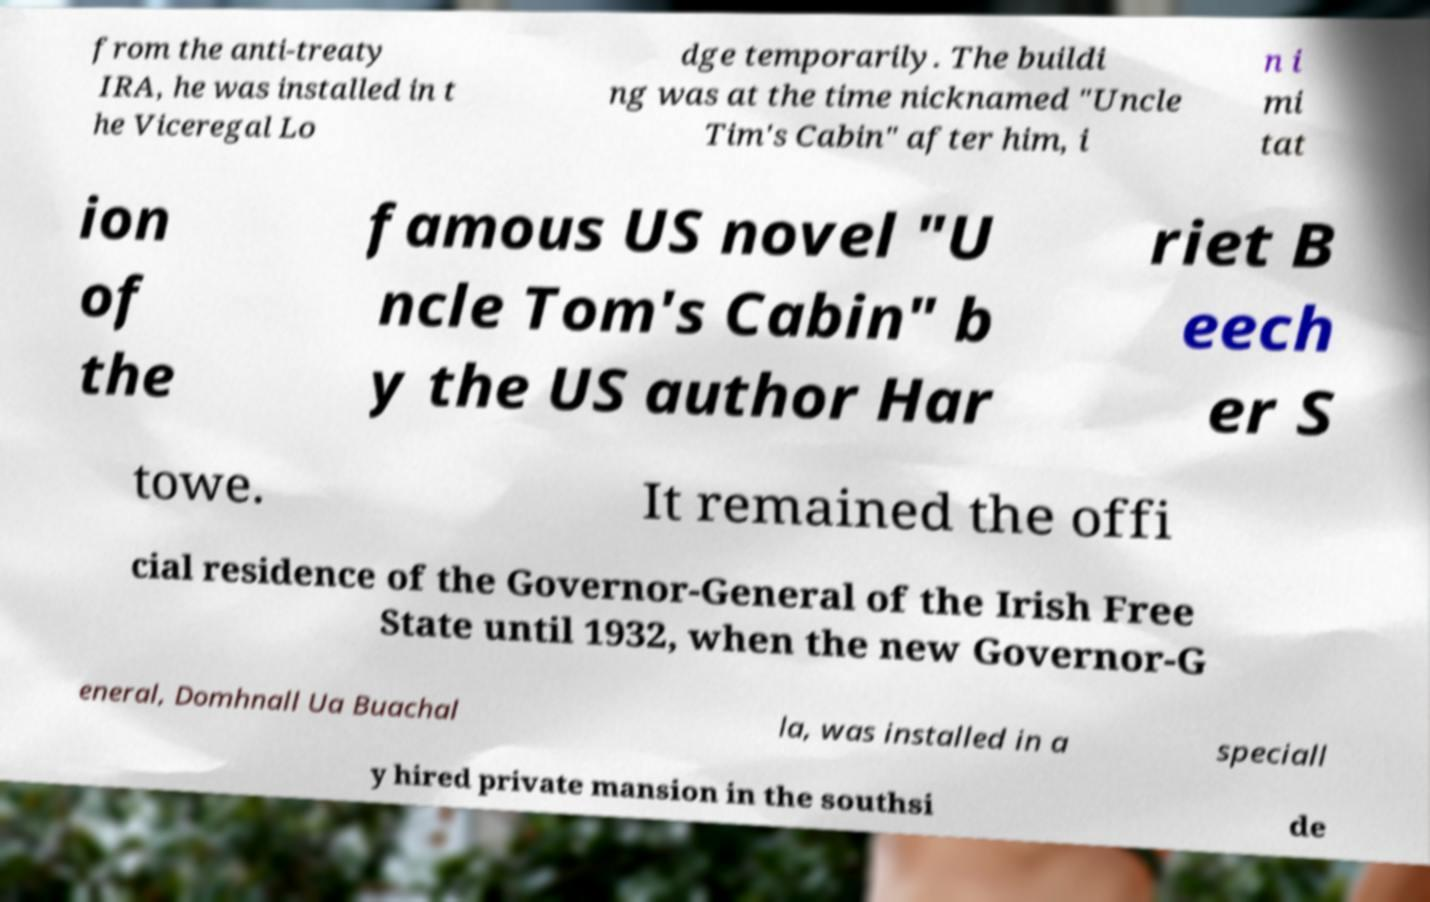Could you assist in decoding the text presented in this image and type it out clearly? from the anti-treaty IRA, he was installed in t he Viceregal Lo dge temporarily. The buildi ng was at the time nicknamed "Uncle Tim's Cabin" after him, i n i mi tat ion of the famous US novel "U ncle Tom's Cabin" b y the US author Har riet B eech er S towe. It remained the offi cial residence of the Governor-General of the Irish Free State until 1932, when the new Governor-G eneral, Domhnall Ua Buachal la, was installed in a speciall y hired private mansion in the southsi de 